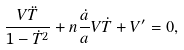<formula> <loc_0><loc_0><loc_500><loc_500>\frac { V \ddot { T } } { 1 - \dot { T } ^ { 2 } } + n \frac { \dot { a } } { a } V \dot { T } + V ^ { \prime } = 0 ,</formula> 